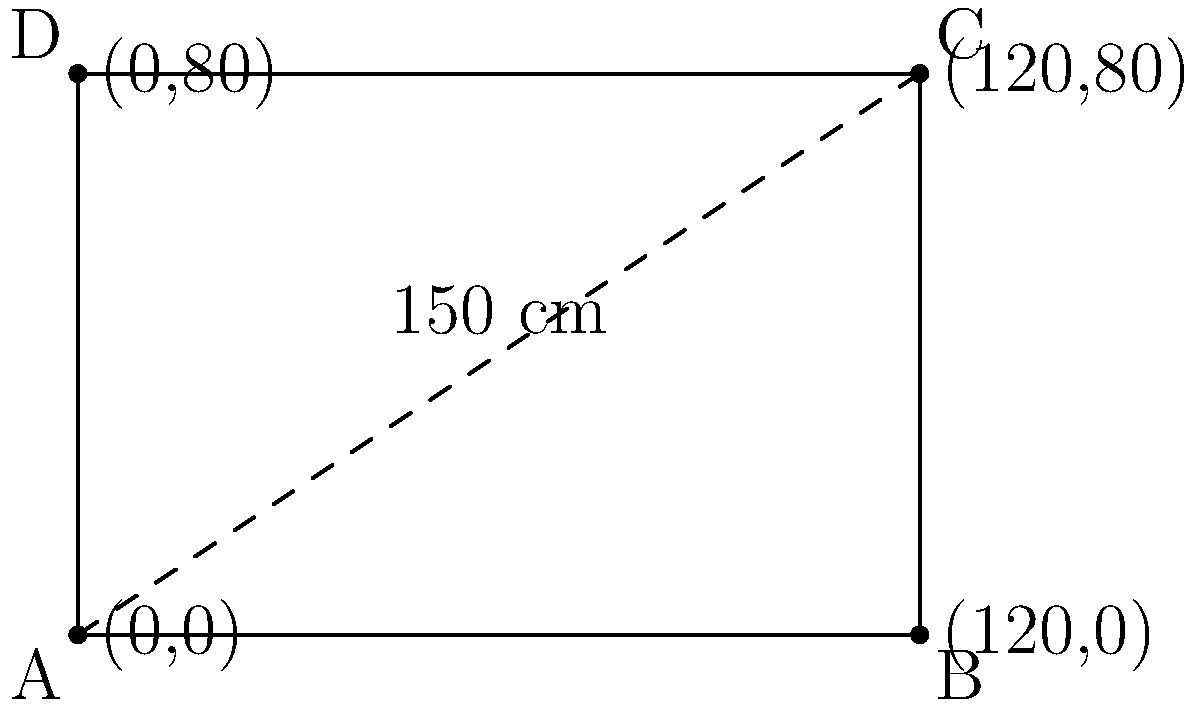The local football team in Terni wants to create a rectangular banner for their next match. The diagonal of the banner measures 150 cm. If the length of the banner is 1.5 times its width, calculate the perimeter of the banner. Let's approach this step-by-step:

1) Let the width of the banner be $x$ cm and the length be $1.5x$ cm.

2) Using the Pythagorean theorem for the diagonal:
   $x^2 + (1.5x)^2 = 150^2$

3) Simplify:
   $x^2 + 2.25x^2 = 22500$
   $3.25x^2 = 22500$

4) Solve for $x$:
   $x^2 = 22500 / 3.25 = 6923.08$
   $x = \sqrt{6923.08} \approx 83.2$ cm

5) The width is approximately 83.2 cm, so the length is:
   $1.5 * 83.2 = 124.8$ cm

6) The perimeter of a rectangle is given by $2(l + w)$, where $l$ is length and $w$ is width:
   Perimeter $= 2(124.8 + 83.2) = 2(208) = 416$ cm

Therefore, the perimeter of the banner is approximately 416 cm.
Answer: 416 cm 